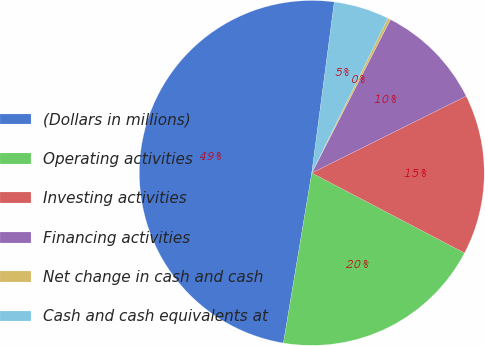<chart> <loc_0><loc_0><loc_500><loc_500><pie_chart><fcel>(Dollars in millions)<fcel>Operating activities<fcel>Investing activities<fcel>Financing activities<fcel>Net change in cash and cash<fcel>Cash and cash equivalents at<nl><fcel>49.46%<fcel>19.95%<fcel>15.03%<fcel>10.11%<fcel>0.27%<fcel>5.19%<nl></chart> 